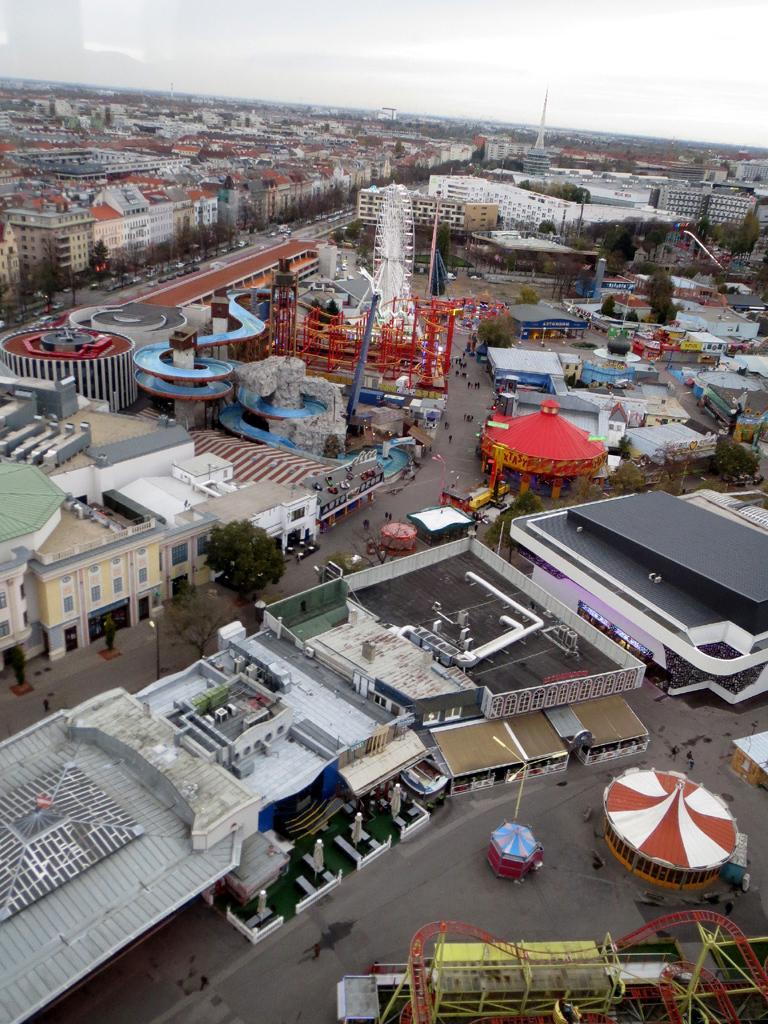How would you summarize this image in a sentence or two? This is an image of the busy street where I can see there are so many buildings, people walking on the streets of road and also there are some cars riding on the roads. 